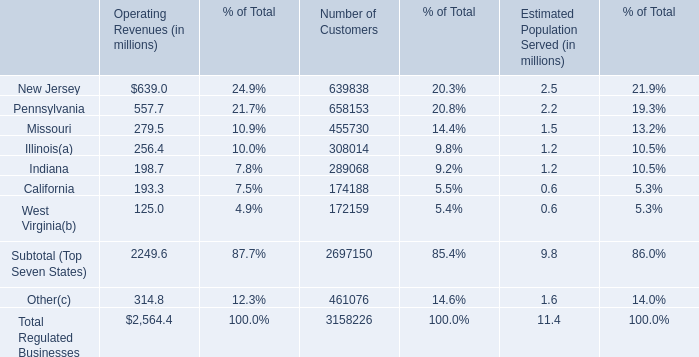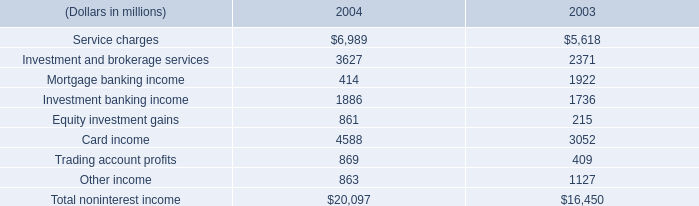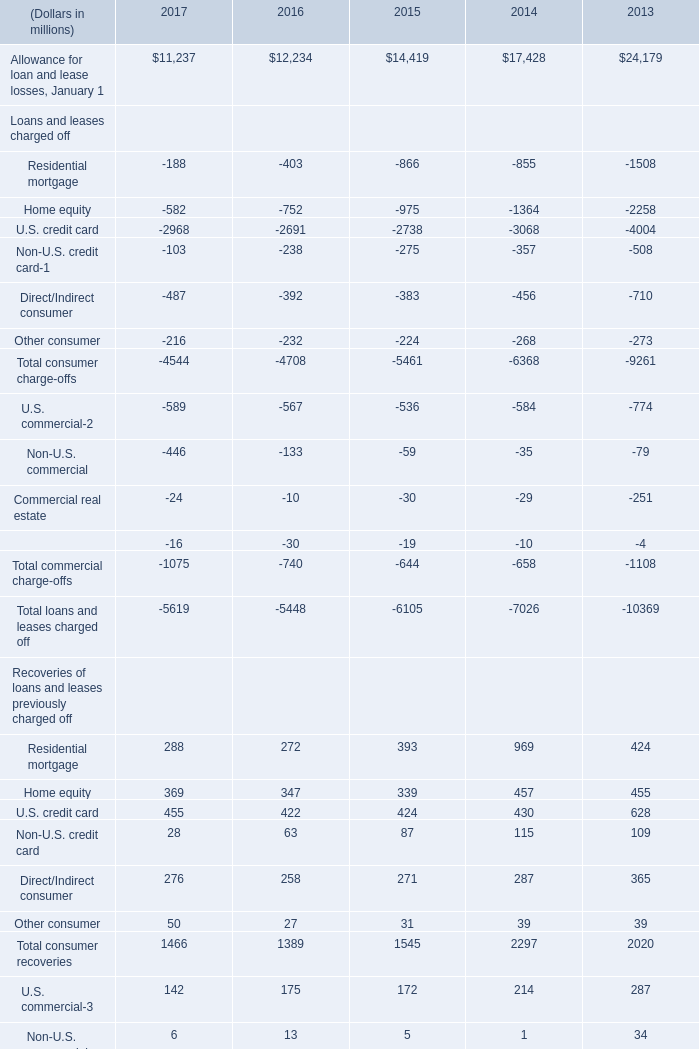what's the total amount of Home equity Loans and leases charged off of 2014, and Investment banking income of 2004 ? 
Computations: (1364.0 + 1886.0)
Answer: 3250.0. What is the total amount of Allowance for loan and lease losses, January 1 of 2016, and Service charges of 2004 ? 
Computations: (12234.0 + 6989.0)
Answer: 19223.0. 